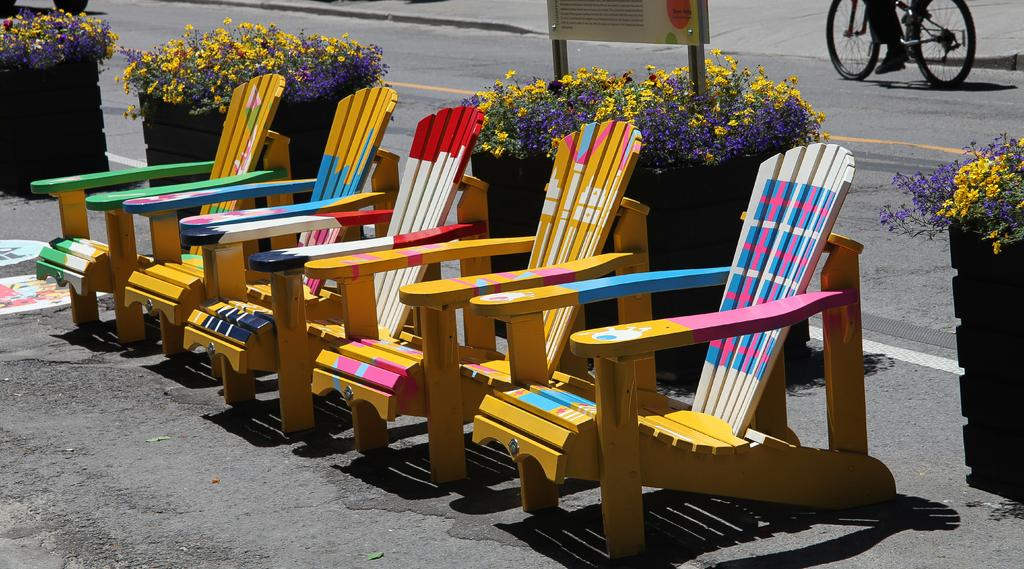What type of furniture is present in the image? There are wooden chairs in the image. What else can be seen in the image besides the wooden chairs? There are flowerpots in the image. What activity is being performed by the person in the image? There is a person riding a bicycle on the road in the image. What is the design of the camp in the image? There is no camp present in the image; it features wooden chairs, flowerpots, and a person riding a bicycle on the road. 